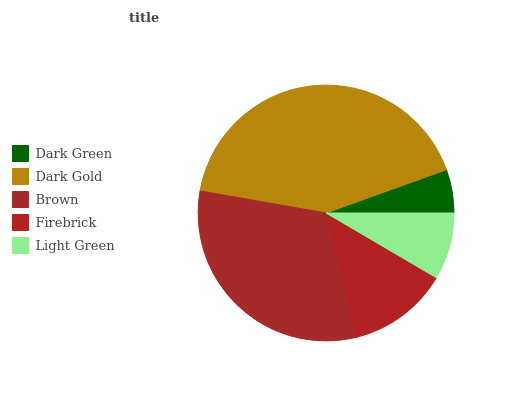Is Dark Green the minimum?
Answer yes or no. Yes. Is Dark Gold the maximum?
Answer yes or no. Yes. Is Brown the minimum?
Answer yes or no. No. Is Brown the maximum?
Answer yes or no. No. Is Dark Gold greater than Brown?
Answer yes or no. Yes. Is Brown less than Dark Gold?
Answer yes or no. Yes. Is Brown greater than Dark Gold?
Answer yes or no. No. Is Dark Gold less than Brown?
Answer yes or no. No. Is Firebrick the high median?
Answer yes or no. Yes. Is Firebrick the low median?
Answer yes or no. Yes. Is Dark Gold the high median?
Answer yes or no. No. Is Dark Gold the low median?
Answer yes or no. No. 